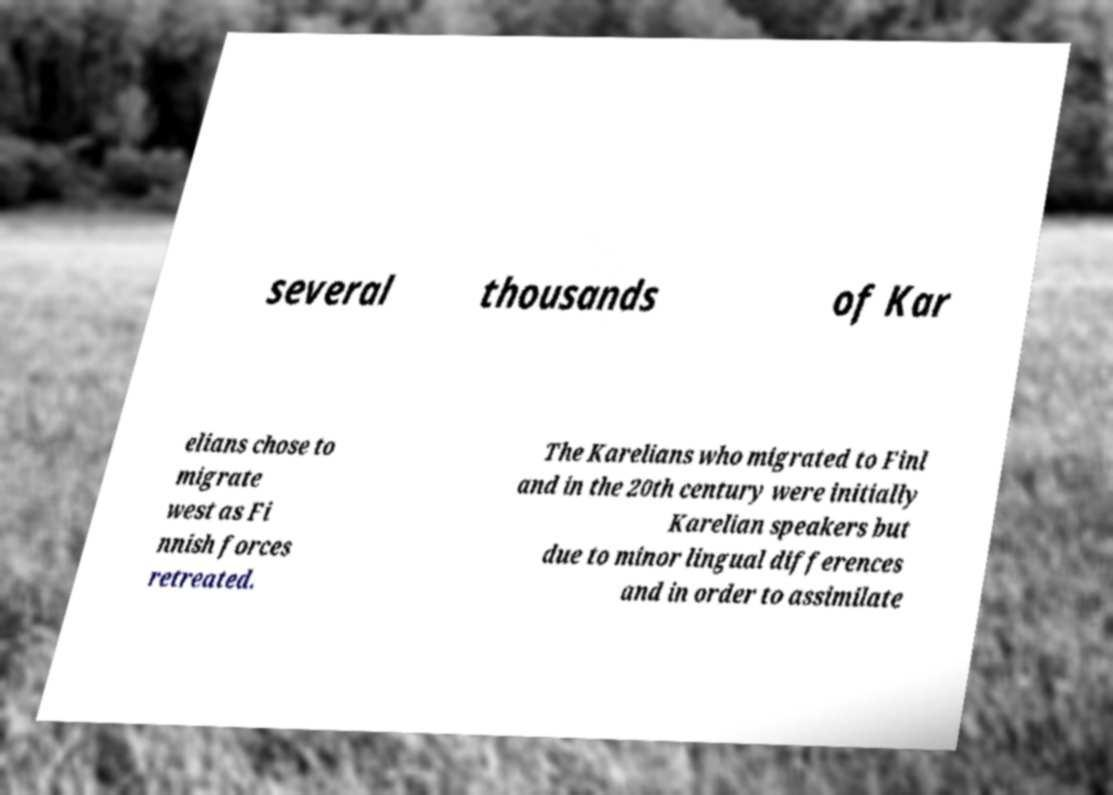Can you read and provide the text displayed in the image?This photo seems to have some interesting text. Can you extract and type it out for me? several thousands of Kar elians chose to migrate west as Fi nnish forces retreated. The Karelians who migrated to Finl and in the 20th century were initially Karelian speakers but due to minor lingual differences and in order to assimilate 